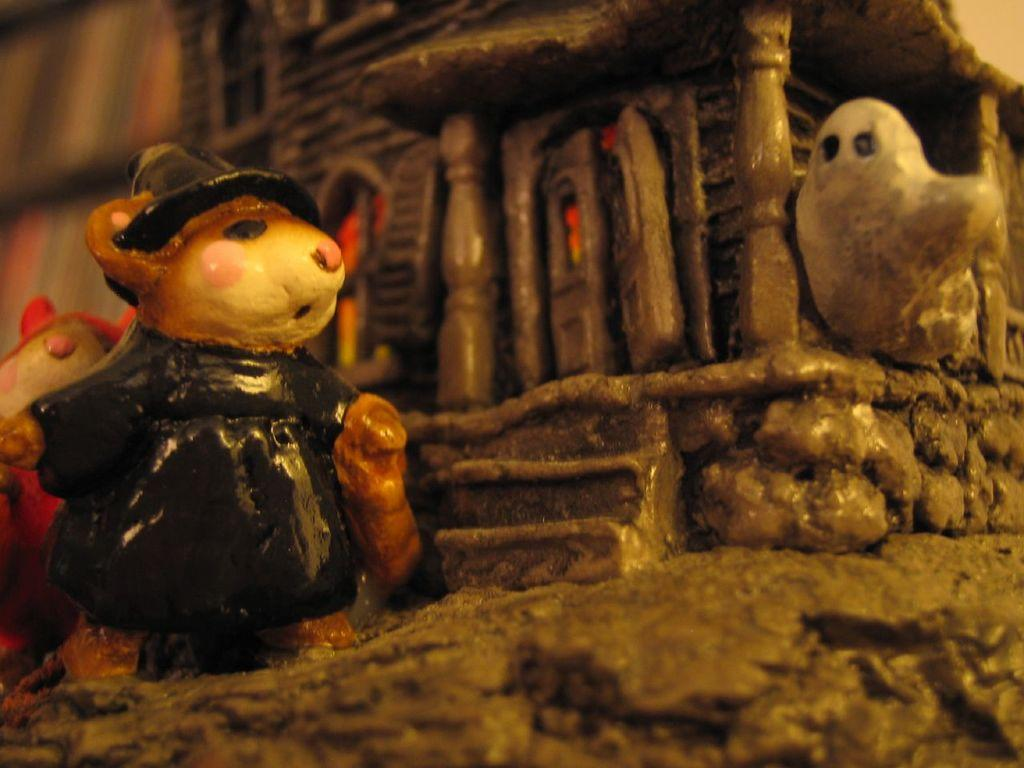What type of sculptures can be seen in the image? There are sculptures of animals, a bird, a building, doors, pillars, and stones in the image. Can you describe the sculpture of a bird in the image? Yes, there is a sculpture of a bird in the image. What other types of structures are depicted in the sculptures? The sculptures include a building, doors, and pillars. Are there any natural elements represented in the sculptures? Yes, there are sculptures of stones in the image. How does the image appear in terms of editing or manipulation? The image appears to be an edited photo. Can you see any planes in the image? No, there are no planes present in the image. Is there a crown visible on any of the sculptures in the image? No, there is no crown visible on any of the sculptures in the image. 